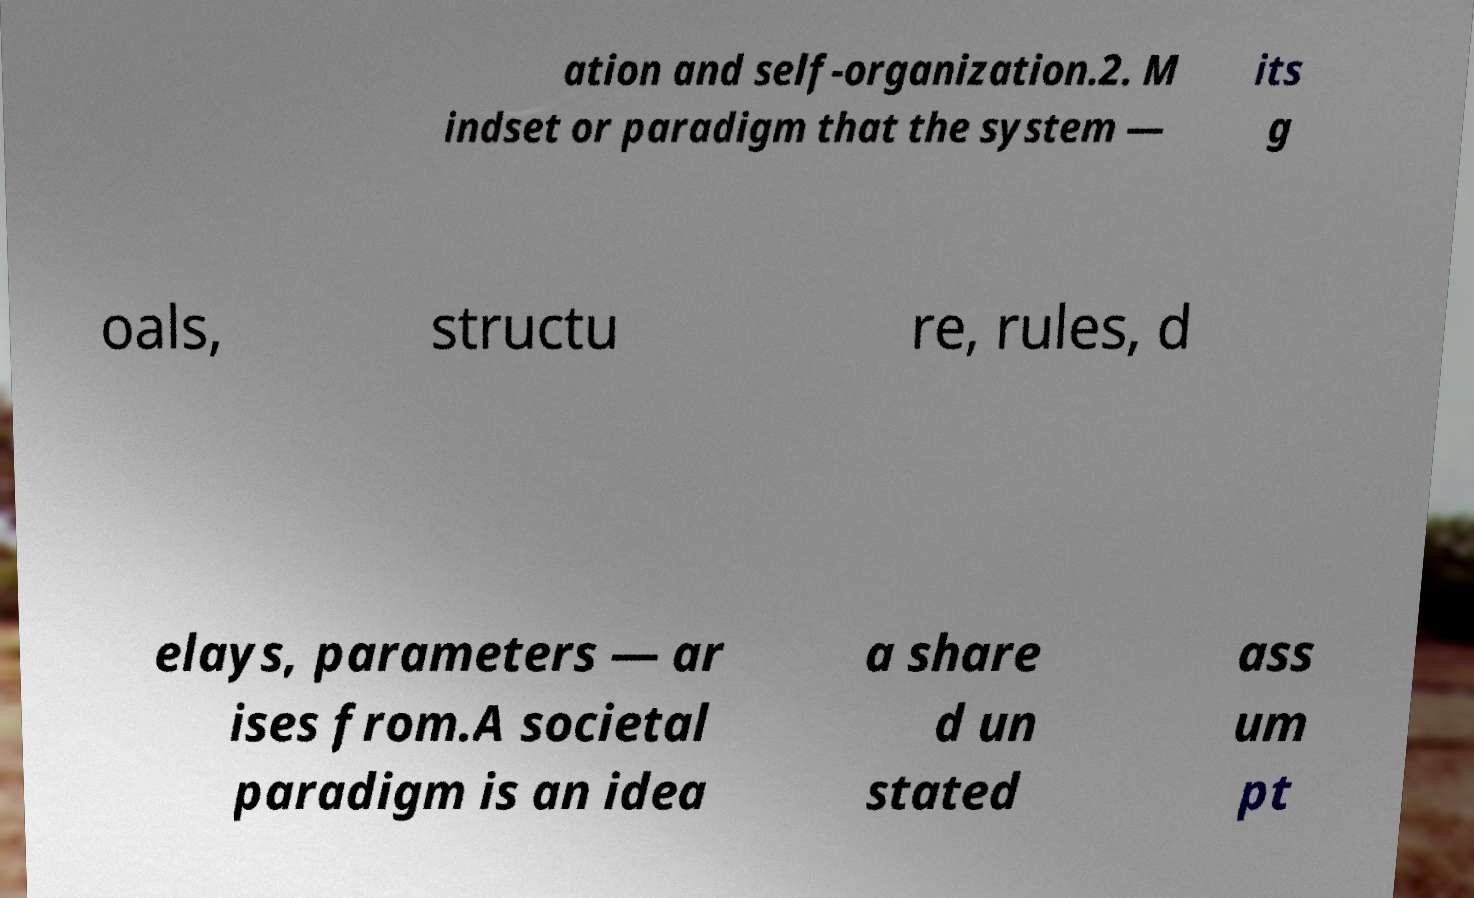I need the written content from this picture converted into text. Can you do that? ation and self-organization.2. M indset or paradigm that the system — its g oals, structu re, rules, d elays, parameters — ar ises from.A societal paradigm is an idea a share d un stated ass um pt 